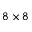<formula> <loc_0><loc_0><loc_500><loc_500>8 \times 8</formula> 